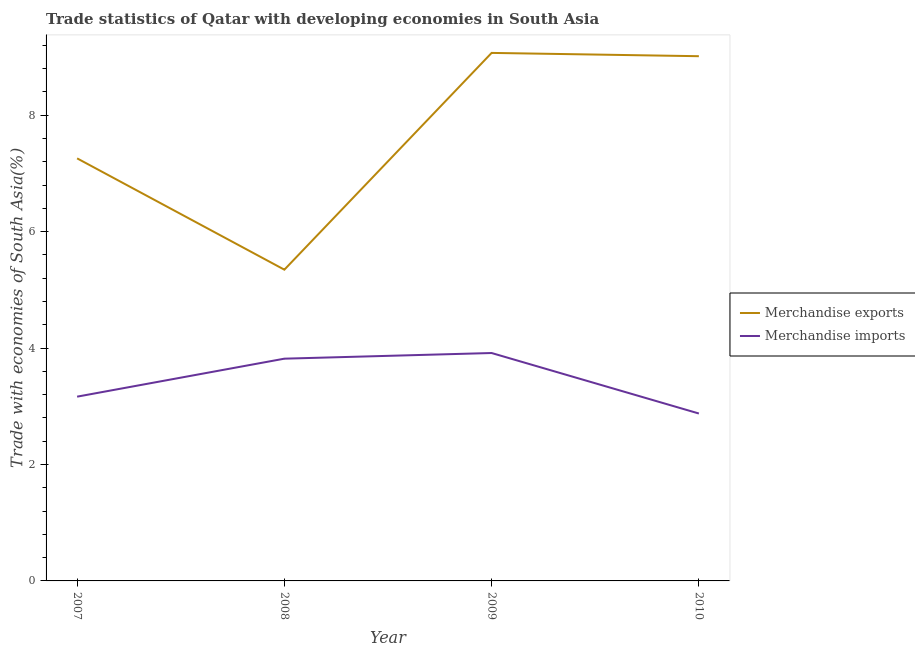How many different coloured lines are there?
Provide a succinct answer. 2. Does the line corresponding to merchandise imports intersect with the line corresponding to merchandise exports?
Offer a very short reply. No. Is the number of lines equal to the number of legend labels?
Offer a very short reply. Yes. What is the merchandise imports in 2010?
Provide a succinct answer. 2.88. Across all years, what is the maximum merchandise imports?
Provide a succinct answer. 3.91. Across all years, what is the minimum merchandise imports?
Offer a very short reply. 2.88. In which year was the merchandise exports minimum?
Ensure brevity in your answer.  2008. What is the total merchandise imports in the graph?
Offer a terse response. 13.77. What is the difference between the merchandise imports in 2007 and that in 2008?
Ensure brevity in your answer.  -0.65. What is the difference between the merchandise imports in 2010 and the merchandise exports in 2009?
Offer a very short reply. -6.19. What is the average merchandise exports per year?
Provide a short and direct response. 7.67. In the year 2007, what is the difference between the merchandise imports and merchandise exports?
Your response must be concise. -4.09. What is the ratio of the merchandise imports in 2007 to that in 2008?
Offer a very short reply. 0.83. Is the merchandise exports in 2008 less than that in 2010?
Ensure brevity in your answer.  Yes. What is the difference between the highest and the second highest merchandise exports?
Make the answer very short. 0.06. What is the difference between the highest and the lowest merchandise exports?
Provide a short and direct response. 3.72. Is the merchandise exports strictly greater than the merchandise imports over the years?
Ensure brevity in your answer.  Yes. Is the merchandise imports strictly less than the merchandise exports over the years?
Offer a very short reply. Yes. How many years are there in the graph?
Your answer should be compact. 4. Are the values on the major ticks of Y-axis written in scientific E-notation?
Your answer should be compact. No. Where does the legend appear in the graph?
Give a very brief answer. Center right. How many legend labels are there?
Your answer should be compact. 2. How are the legend labels stacked?
Offer a very short reply. Vertical. What is the title of the graph?
Ensure brevity in your answer.  Trade statistics of Qatar with developing economies in South Asia. Does "Goods and services" appear as one of the legend labels in the graph?
Keep it short and to the point. No. What is the label or title of the X-axis?
Your response must be concise. Year. What is the label or title of the Y-axis?
Keep it short and to the point. Trade with economies of South Asia(%). What is the Trade with economies of South Asia(%) of Merchandise exports in 2007?
Your answer should be compact. 7.26. What is the Trade with economies of South Asia(%) of Merchandise imports in 2007?
Make the answer very short. 3.16. What is the Trade with economies of South Asia(%) in Merchandise exports in 2008?
Make the answer very short. 5.35. What is the Trade with economies of South Asia(%) in Merchandise imports in 2008?
Make the answer very short. 3.82. What is the Trade with economies of South Asia(%) in Merchandise exports in 2009?
Give a very brief answer. 9.07. What is the Trade with economies of South Asia(%) of Merchandise imports in 2009?
Provide a succinct answer. 3.91. What is the Trade with economies of South Asia(%) in Merchandise exports in 2010?
Provide a short and direct response. 9.01. What is the Trade with economies of South Asia(%) of Merchandise imports in 2010?
Your response must be concise. 2.88. Across all years, what is the maximum Trade with economies of South Asia(%) of Merchandise exports?
Make the answer very short. 9.07. Across all years, what is the maximum Trade with economies of South Asia(%) of Merchandise imports?
Offer a very short reply. 3.91. Across all years, what is the minimum Trade with economies of South Asia(%) of Merchandise exports?
Ensure brevity in your answer.  5.35. Across all years, what is the minimum Trade with economies of South Asia(%) of Merchandise imports?
Your answer should be compact. 2.88. What is the total Trade with economies of South Asia(%) in Merchandise exports in the graph?
Keep it short and to the point. 30.68. What is the total Trade with economies of South Asia(%) in Merchandise imports in the graph?
Provide a short and direct response. 13.77. What is the difference between the Trade with economies of South Asia(%) in Merchandise exports in 2007 and that in 2008?
Your response must be concise. 1.91. What is the difference between the Trade with economies of South Asia(%) of Merchandise imports in 2007 and that in 2008?
Ensure brevity in your answer.  -0.65. What is the difference between the Trade with economies of South Asia(%) in Merchandise exports in 2007 and that in 2009?
Provide a short and direct response. -1.81. What is the difference between the Trade with economies of South Asia(%) of Merchandise imports in 2007 and that in 2009?
Your answer should be very brief. -0.75. What is the difference between the Trade with economies of South Asia(%) in Merchandise exports in 2007 and that in 2010?
Give a very brief answer. -1.75. What is the difference between the Trade with economies of South Asia(%) in Merchandise imports in 2007 and that in 2010?
Offer a terse response. 0.29. What is the difference between the Trade with economies of South Asia(%) of Merchandise exports in 2008 and that in 2009?
Your response must be concise. -3.72. What is the difference between the Trade with economies of South Asia(%) of Merchandise imports in 2008 and that in 2009?
Give a very brief answer. -0.1. What is the difference between the Trade with economies of South Asia(%) of Merchandise exports in 2008 and that in 2010?
Your response must be concise. -3.67. What is the difference between the Trade with economies of South Asia(%) of Merchandise imports in 2008 and that in 2010?
Offer a very short reply. 0.94. What is the difference between the Trade with economies of South Asia(%) of Merchandise exports in 2009 and that in 2010?
Offer a very short reply. 0.06. What is the difference between the Trade with economies of South Asia(%) in Merchandise imports in 2009 and that in 2010?
Offer a terse response. 1.04. What is the difference between the Trade with economies of South Asia(%) of Merchandise exports in 2007 and the Trade with economies of South Asia(%) of Merchandise imports in 2008?
Your response must be concise. 3.44. What is the difference between the Trade with economies of South Asia(%) in Merchandise exports in 2007 and the Trade with economies of South Asia(%) in Merchandise imports in 2009?
Your answer should be very brief. 3.34. What is the difference between the Trade with economies of South Asia(%) in Merchandise exports in 2007 and the Trade with economies of South Asia(%) in Merchandise imports in 2010?
Offer a very short reply. 4.38. What is the difference between the Trade with economies of South Asia(%) in Merchandise exports in 2008 and the Trade with economies of South Asia(%) in Merchandise imports in 2009?
Offer a very short reply. 1.43. What is the difference between the Trade with economies of South Asia(%) of Merchandise exports in 2008 and the Trade with economies of South Asia(%) of Merchandise imports in 2010?
Give a very brief answer. 2.47. What is the difference between the Trade with economies of South Asia(%) of Merchandise exports in 2009 and the Trade with economies of South Asia(%) of Merchandise imports in 2010?
Keep it short and to the point. 6.19. What is the average Trade with economies of South Asia(%) in Merchandise exports per year?
Offer a terse response. 7.67. What is the average Trade with economies of South Asia(%) in Merchandise imports per year?
Provide a short and direct response. 3.44. In the year 2007, what is the difference between the Trade with economies of South Asia(%) in Merchandise exports and Trade with economies of South Asia(%) in Merchandise imports?
Your answer should be compact. 4.09. In the year 2008, what is the difference between the Trade with economies of South Asia(%) of Merchandise exports and Trade with economies of South Asia(%) of Merchandise imports?
Offer a terse response. 1.53. In the year 2009, what is the difference between the Trade with economies of South Asia(%) of Merchandise exports and Trade with economies of South Asia(%) of Merchandise imports?
Your response must be concise. 5.15. In the year 2010, what is the difference between the Trade with economies of South Asia(%) in Merchandise exports and Trade with economies of South Asia(%) in Merchandise imports?
Give a very brief answer. 6.14. What is the ratio of the Trade with economies of South Asia(%) of Merchandise exports in 2007 to that in 2008?
Ensure brevity in your answer.  1.36. What is the ratio of the Trade with economies of South Asia(%) in Merchandise imports in 2007 to that in 2008?
Offer a terse response. 0.83. What is the ratio of the Trade with economies of South Asia(%) in Merchandise exports in 2007 to that in 2009?
Keep it short and to the point. 0.8. What is the ratio of the Trade with economies of South Asia(%) of Merchandise imports in 2007 to that in 2009?
Ensure brevity in your answer.  0.81. What is the ratio of the Trade with economies of South Asia(%) of Merchandise exports in 2007 to that in 2010?
Your answer should be compact. 0.81. What is the ratio of the Trade with economies of South Asia(%) in Merchandise imports in 2007 to that in 2010?
Offer a terse response. 1.1. What is the ratio of the Trade with economies of South Asia(%) in Merchandise exports in 2008 to that in 2009?
Provide a succinct answer. 0.59. What is the ratio of the Trade with economies of South Asia(%) in Merchandise imports in 2008 to that in 2009?
Make the answer very short. 0.98. What is the ratio of the Trade with economies of South Asia(%) of Merchandise exports in 2008 to that in 2010?
Make the answer very short. 0.59. What is the ratio of the Trade with economies of South Asia(%) of Merchandise imports in 2008 to that in 2010?
Your response must be concise. 1.33. What is the ratio of the Trade with economies of South Asia(%) of Merchandise imports in 2009 to that in 2010?
Provide a succinct answer. 1.36. What is the difference between the highest and the second highest Trade with economies of South Asia(%) in Merchandise exports?
Provide a succinct answer. 0.06. What is the difference between the highest and the second highest Trade with economies of South Asia(%) in Merchandise imports?
Make the answer very short. 0.1. What is the difference between the highest and the lowest Trade with economies of South Asia(%) of Merchandise exports?
Keep it short and to the point. 3.72. What is the difference between the highest and the lowest Trade with economies of South Asia(%) of Merchandise imports?
Keep it short and to the point. 1.04. 